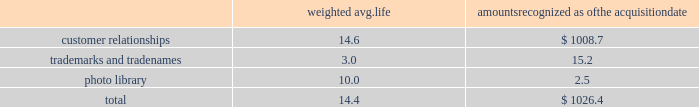Westrock company notes to consolidated financial statements fffd ( continued ) the table summarizes the weighted average life and the allocation to intangible assets recognized in the mps acquisition , excluding goodwill ( in millions ) : weighted avg .
Amounts recognized as the acquisition .
None of the intangibles has significant residual value .
We are amortizing the customer relationship intangibles over estimated useful lives ranging from 13 to 16 years based on a straight-line basis because the amortization pattern was not reliably determinable .
Star pizza acquisition on march 13 , 2017 , we completed the star pizza acquisition .
The transaction provided us with a leadership position in the fast growing small-run pizza box market and increases our vertical integration .
The purchase price was $ 34.6 million , net of a $ 0.7 million working capital settlement .
We have fully integrated the approximately 22000 tons of containerboard used by star pizza annually .
We have included the financial results of the acquired assets since the date of the acquisition in our corrugated packaging segment .
The purchase price allocation for the acquisition primarily included $ 24.8 million of customer relationship intangible assets and $ 2.2 million of goodwill .
We are amortizing the customer relationship intangibles over 10 years based on a straight-line basis because the amortization pattern was not reliably determinable .
The fair value assigned to goodwill is primarily attributable to buyer-specific synergies expected to arise after the acquisition ( e.g. , enhanced reach of the combined organization and other synergies ) , and the assembled work force .
The goodwill and intangibles are amortizable for income tax purposes .
Packaging acquisition on january 19 , 2016 , we completed the packaging acquisition .
The entities acquired provide value-added folding carton and litho-laminated display packaging solutions .
The purchase price was $ 94.1 million , net of cash received of $ 1.7 million , a working capital settlement and a $ 3.5 million escrow receipt in the first quarter of fiscal 2017 .
The transaction is subject to an election under section 338 ( h ) ( 10 ) of the code that increases the u.s .
Tax basis in the acquired u.s .
Entities .
We believe the transaction has provided us with attractive and complementary customers , markets and facilities .
We have included the financial results of the acquired entities since the date of the acquisition in our consumer packaging segment .
The purchase price allocation for the acquisition primarily included $ 55.0 million of property , plant and equipment , $ 10.5 million of customer relationship intangible assets , $ 9.3 million of goodwill and $ 25.8 million of liabilities , including $ 1.3 million of debt .
We are amortizing the customer relationship intangibles over estimated useful lives ranging from 9 to 15 years based on a straight-line basis because the amortization pattern was not reliably determinable .
The fair value assigned to goodwill is primarily attributable to buyer-specific synergies expected to arise after the acquisition ( e.g. , enhanced reach of the combined organization and other synergies ) , and the assembled work force .
The goodwill and intangibles of the u.s .
Entities are amortizable for income tax purposes .
Sp fiber on october 1 , 2015 , we completed the sp fiber acquisition in a stock purchase .
The transaction included the acquisition of mills located in dublin , ga and newberg , or , which produce lightweight recycled containerboard and kraft and bag paper .
The newberg mill also produced newsprint .
As part of the transaction , we also acquired sp fiber's 48% ( 48 % ) interest in gps .
Gps is a joint venture providing steam to the dublin mill and electricity to georgia power .
The purchase price was $ 278.8 million , net of cash received of $ 9.2 million and a working capital .
What percent of the recognized value of the period's acquisition is from the value of trademarks and tradenames? 
Computations: (15.2 / 1026.4)
Answer: 0.01481. 